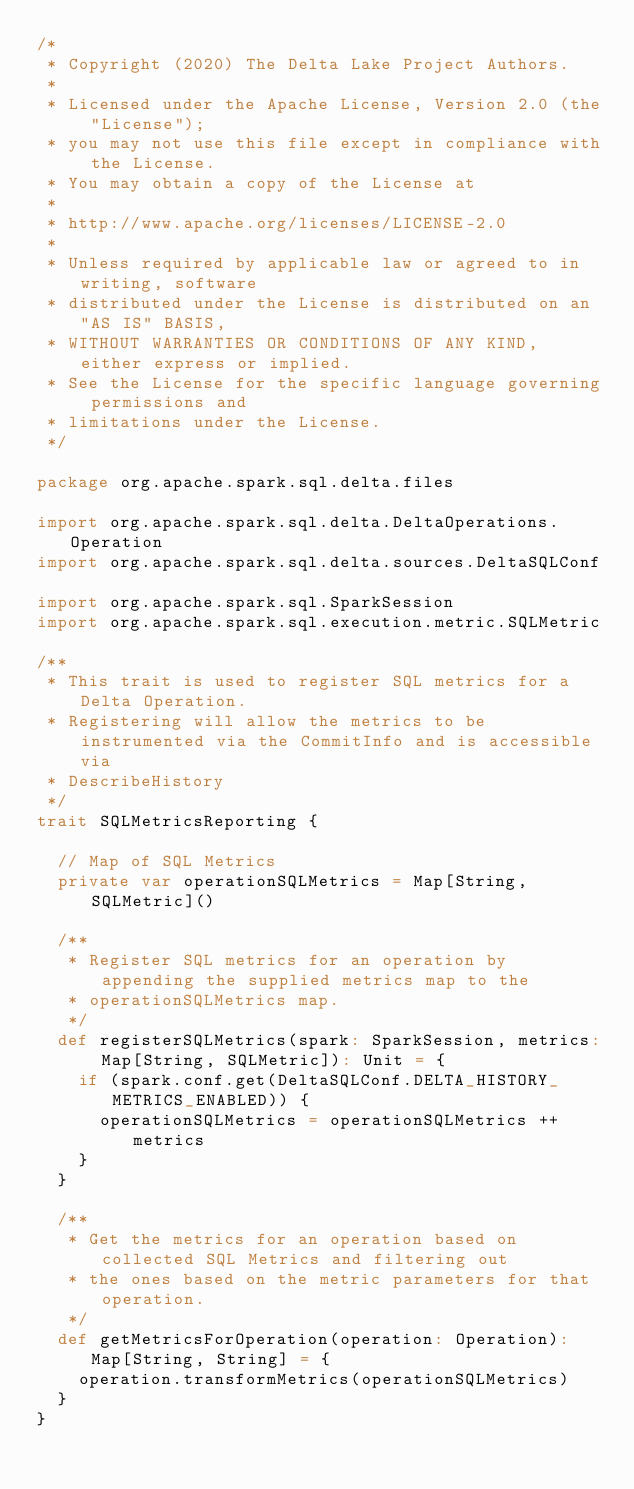Convert code to text. <code><loc_0><loc_0><loc_500><loc_500><_Scala_>/*
 * Copyright (2020) The Delta Lake Project Authors.
 *
 * Licensed under the Apache License, Version 2.0 (the "License");
 * you may not use this file except in compliance with the License.
 * You may obtain a copy of the License at
 *
 * http://www.apache.org/licenses/LICENSE-2.0
 *
 * Unless required by applicable law or agreed to in writing, software
 * distributed under the License is distributed on an "AS IS" BASIS,
 * WITHOUT WARRANTIES OR CONDITIONS OF ANY KIND, either express or implied.
 * See the License for the specific language governing permissions and
 * limitations under the License.
 */

package org.apache.spark.sql.delta.files

import org.apache.spark.sql.delta.DeltaOperations.Operation
import org.apache.spark.sql.delta.sources.DeltaSQLConf

import org.apache.spark.sql.SparkSession
import org.apache.spark.sql.execution.metric.SQLMetric

/**
 * This trait is used to register SQL metrics for a Delta Operation.
 * Registering will allow the metrics to be instrumented via the CommitInfo and is accessible via
 * DescribeHistory
 */
trait SQLMetricsReporting {

  // Map of SQL Metrics
  private var operationSQLMetrics = Map[String, SQLMetric]()

  /**
   * Register SQL metrics for an operation by appending the supplied metrics map to the
   * operationSQLMetrics map.
   */
  def registerSQLMetrics(spark: SparkSession, metrics: Map[String, SQLMetric]): Unit = {
    if (spark.conf.get(DeltaSQLConf.DELTA_HISTORY_METRICS_ENABLED)) {
      operationSQLMetrics = operationSQLMetrics ++ metrics
    }
  }

  /**
   * Get the metrics for an operation based on collected SQL Metrics and filtering out
   * the ones based on the metric parameters for that operation.
   */
  def getMetricsForOperation(operation: Operation): Map[String, String] = {
    operation.transformMetrics(operationSQLMetrics)
  }
}
</code> 